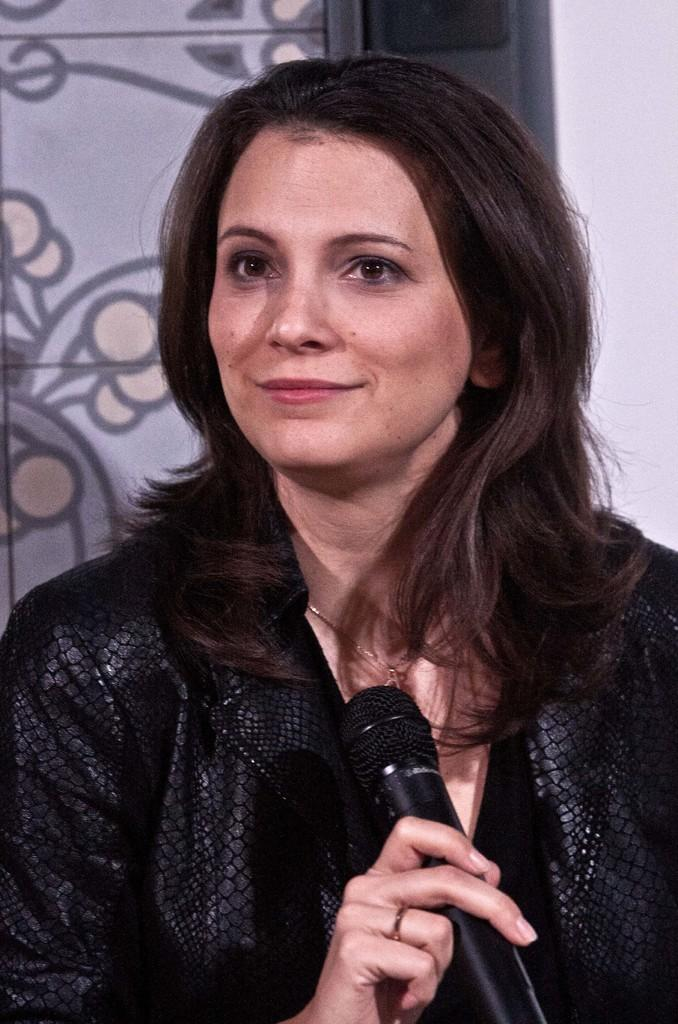Who is the main subject in the image? There is a woman in the image. What is the woman wearing? The woman is wearing a black dress. What is the woman holding in her hand? The woman is holding a microphone in her hand. What can be seen in the background of the image? There is a design on a door in the background of the image. What is the woman writing on the middle of the door in the image? There is no indication in the image that the woman is writing on the door, and there is no mention of a middle part of the door. 